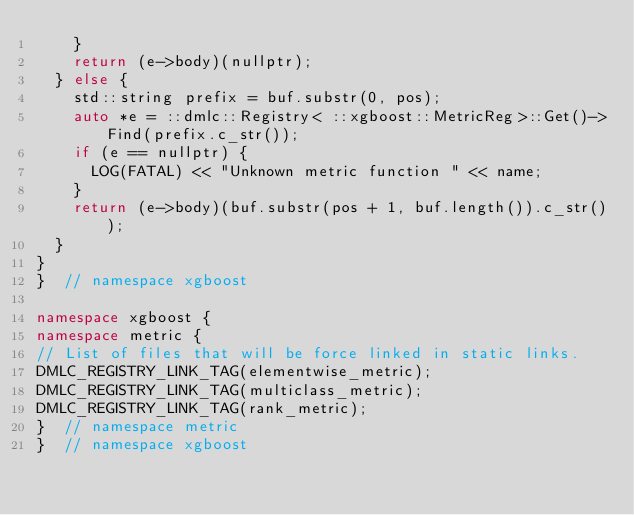<code> <loc_0><loc_0><loc_500><loc_500><_C++_>    }
    return (e->body)(nullptr);
  } else {
    std::string prefix = buf.substr(0, pos);
    auto *e = ::dmlc::Registry< ::xgboost::MetricReg>::Get()->Find(prefix.c_str());
    if (e == nullptr) {
      LOG(FATAL) << "Unknown metric function " << name;
    }
    return (e->body)(buf.substr(pos + 1, buf.length()).c_str());
  }
}
}  // namespace xgboost

namespace xgboost {
namespace metric {
// List of files that will be force linked in static links.
DMLC_REGISTRY_LINK_TAG(elementwise_metric);
DMLC_REGISTRY_LINK_TAG(multiclass_metric);
DMLC_REGISTRY_LINK_TAG(rank_metric);
}  // namespace metric
}  // namespace xgboost
</code> 